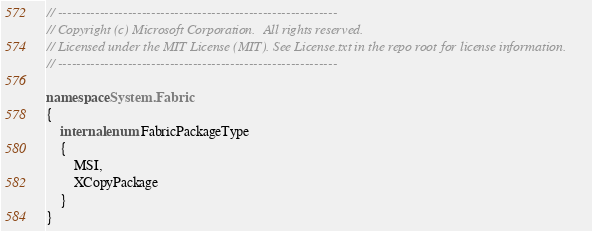<code> <loc_0><loc_0><loc_500><loc_500><_C#_>// ------------------------------------------------------------
// Copyright (c) Microsoft Corporation.  All rights reserved.
// Licensed under the MIT License (MIT). See License.txt in the repo root for license information.
// ------------------------------------------------------------

namespace System.Fabric
{
    internal enum FabricPackageType
    {
        MSI,
        XCopyPackage
    }
}</code> 